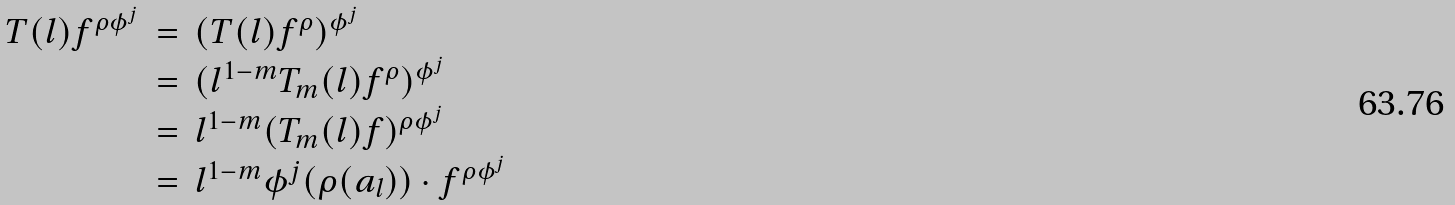<formula> <loc_0><loc_0><loc_500><loc_500>\begin{array} { r c l } T ( l ) f ^ { \rho \phi ^ { j } } & = & ( T ( l ) f ^ { \rho } ) ^ { \phi ^ { j } } \\ \ & = & ( l ^ { 1 - m } T _ { m } ( l ) f ^ { \rho } ) ^ { \phi ^ { j } } \\ \ & = & l ^ { 1 - m } ( T _ { m } ( l ) f ) ^ { \rho \phi ^ { j } } \\ \ & = & l ^ { 1 - m } \phi ^ { j } ( \rho ( a _ { l } ) ) \cdot f ^ { \rho \phi ^ { j } } \end{array}</formula> 